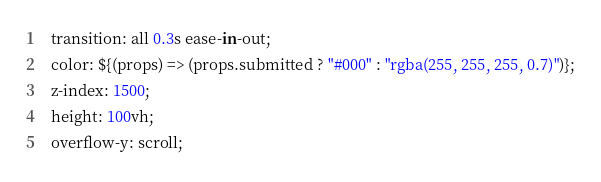<code> <loc_0><loc_0><loc_500><loc_500><_JavaScript_>  transition: all 0.3s ease-in-out;
  color: ${(props) => (props.submitted ? "#000" : "rgba(255, 255, 255, 0.7)")};
  z-index: 1500;
  height: 100vh;
  overflow-y: scroll;</code> 